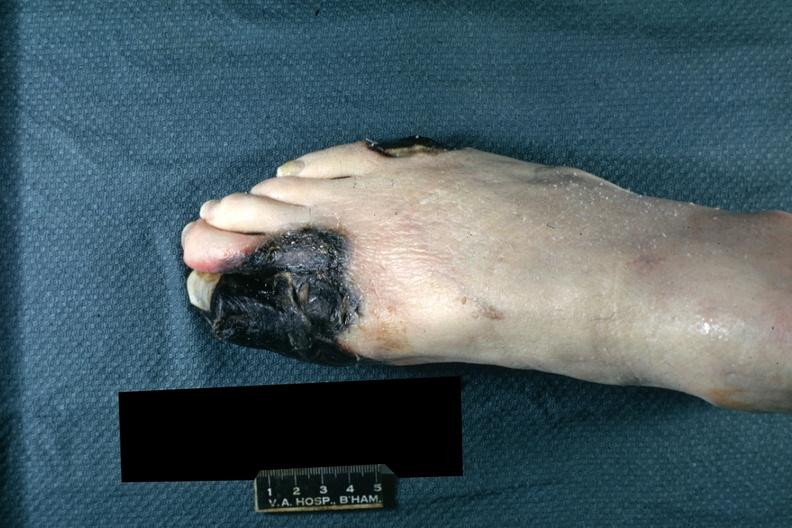what is present?
Answer the question using a single word or phrase. Gangrene 